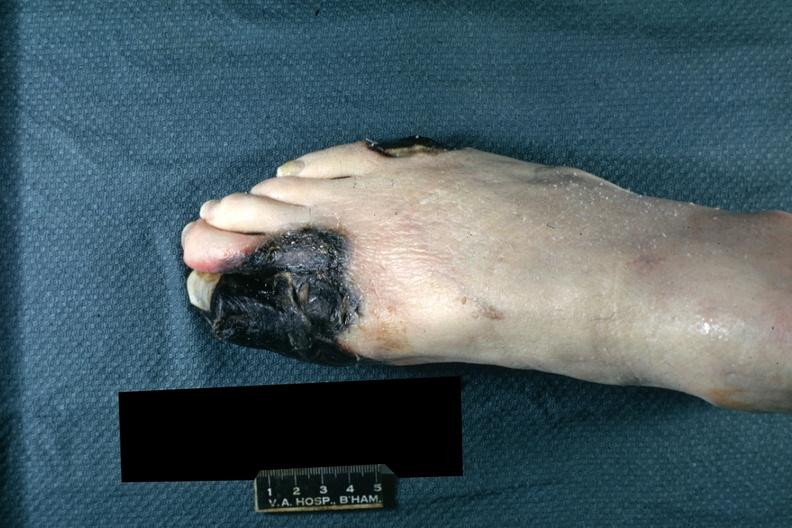what is present?
Answer the question using a single word or phrase. Gangrene 